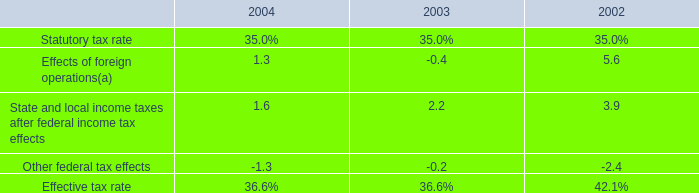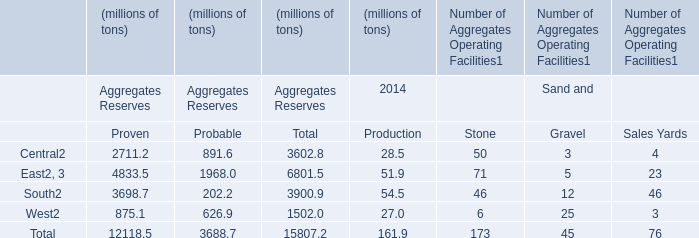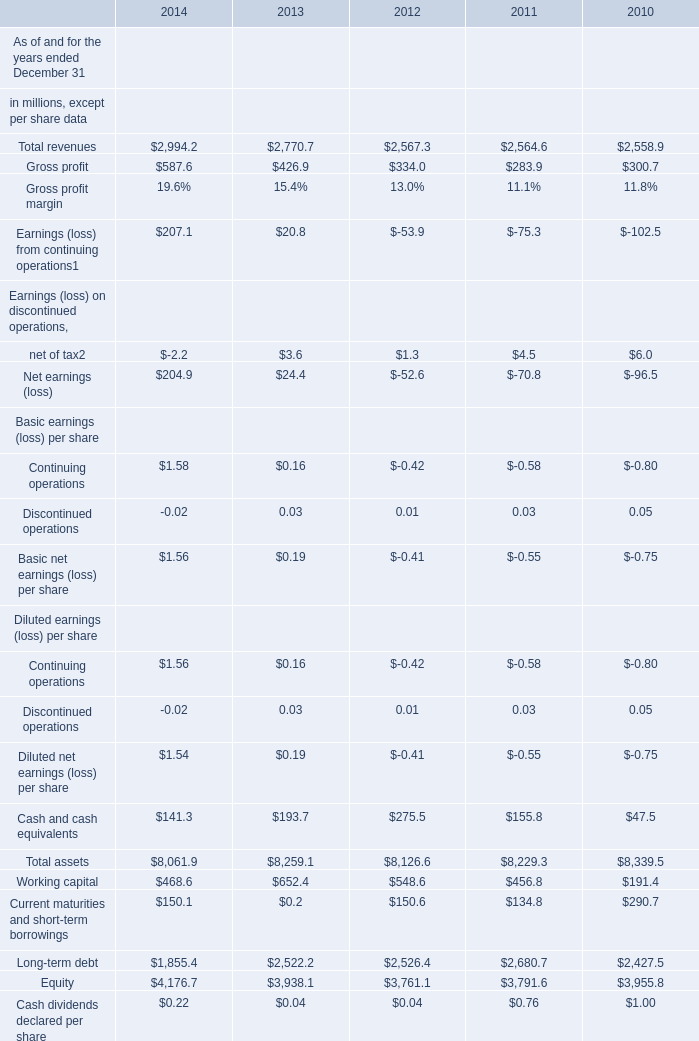What is the value of the Total assets for 2012 ended December 31? (in million) 
Answer: 8126.6. 